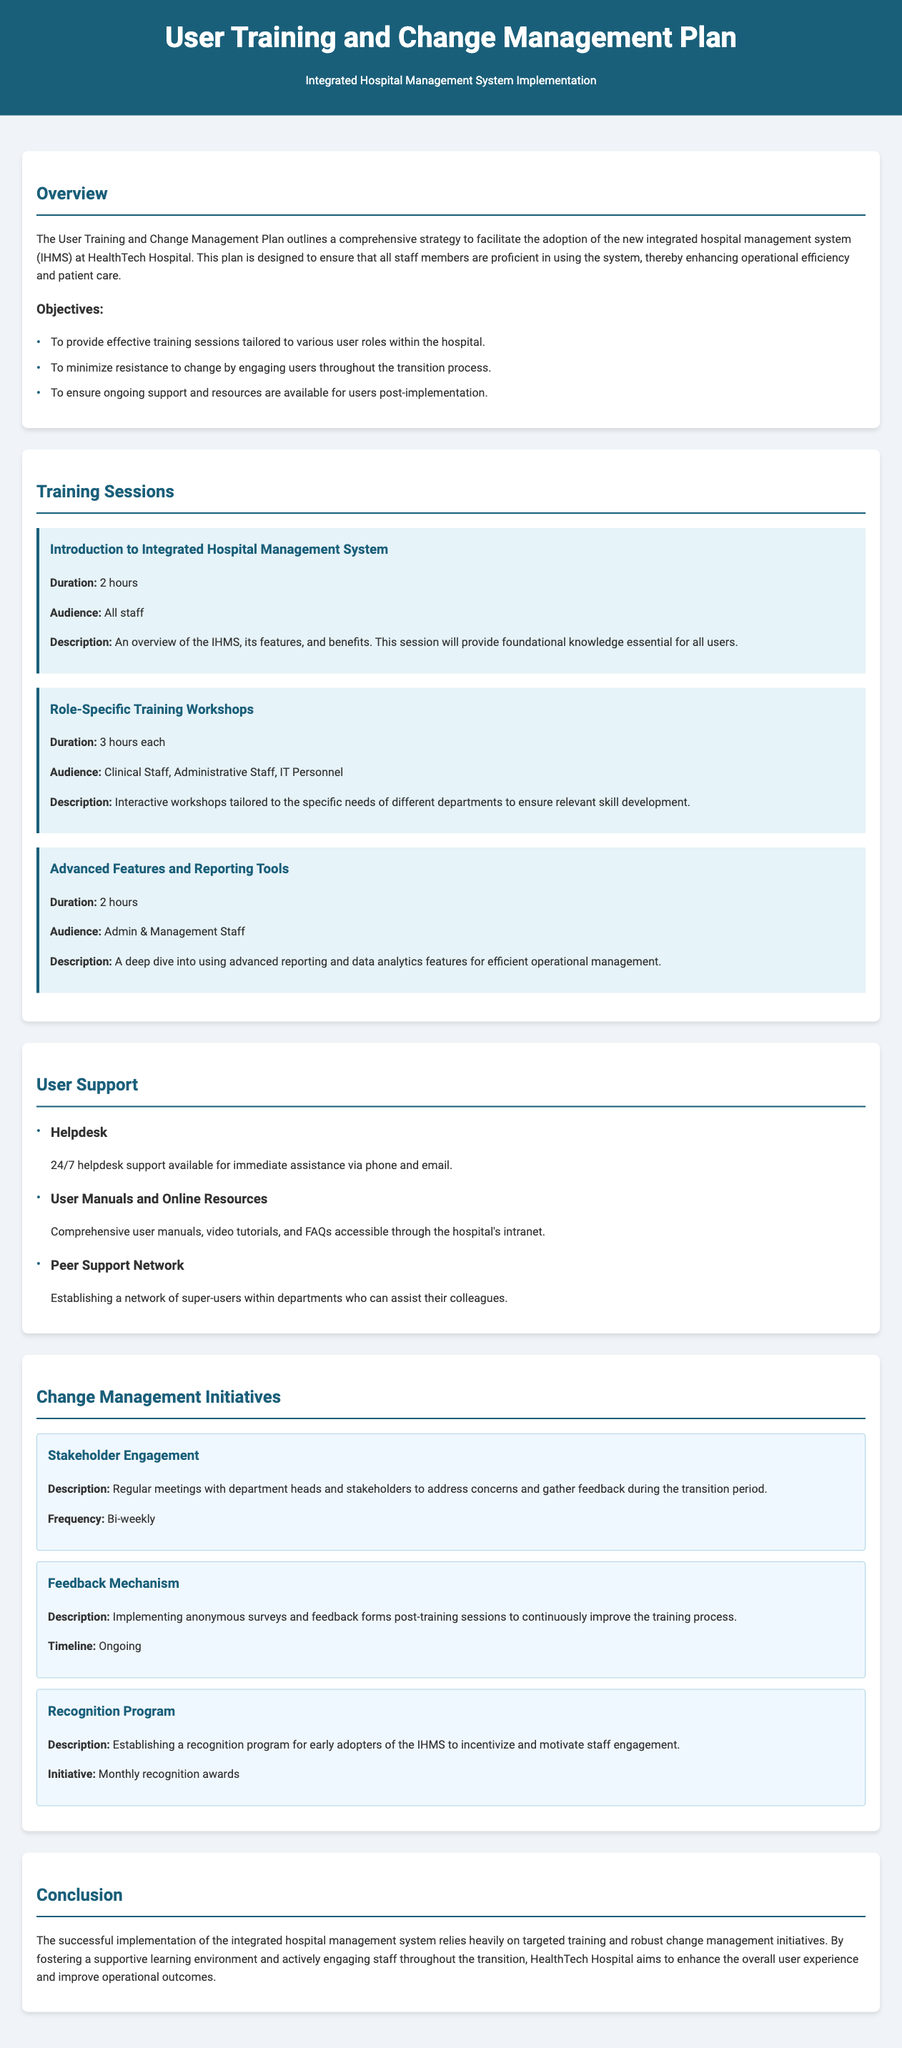what is the title of the plan? The title of the plan is explicitly mentioned in the header of the document.
Answer: User Training and Change Management Plan how long is the "Introduction to Integrated Hospital Management System" session? The duration of this session is specified clearly in the training sessions section.
Answer: 2 hours who is the target audience for "Role-Specific Training Workshops"? The audience for this workshop is mentioned directly in the description of the session related to role-specific training.
Answer: Clinical Staff, Administrative Staff, IT Personnel what frequency is recommended for stakeholder engagement meetings? The document specifies the frequency of these meetings in the change management initiatives section.
Answer: Bi-weekly what type of support is available 24/7 for users? The type of support available anytime is listed in the user support section.
Answer: Helpdesk what is a goal of the change management initiatives? The document outlines the purpose of implementing change management initiatives within the context of user adoption.
Answer: To minimize resistance to change how often are the recognition program awards given? The initiative regarding recognition includes a specific time frame for award distribution.
Answer: Monthly what resources are available for user manuals? The document provides detail on what forms of resources are available for user guidance.
Answer: Online Resources what is the conclusion of the plan emphasizing? The conclusion highlights the overall aim of the plan and its importance for successful implementation.
Answer: Enhance the overall user experience and improve operational outcomes 